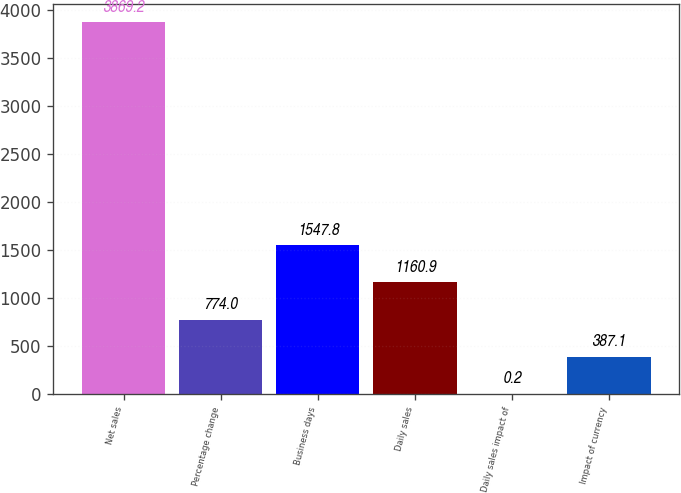Convert chart. <chart><loc_0><loc_0><loc_500><loc_500><bar_chart><fcel>Net sales<fcel>Percentage change<fcel>Business days<fcel>Daily sales<fcel>Daily sales impact of<fcel>Impact of currency<nl><fcel>3869.2<fcel>774<fcel>1547.8<fcel>1160.9<fcel>0.2<fcel>387.1<nl></chart> 